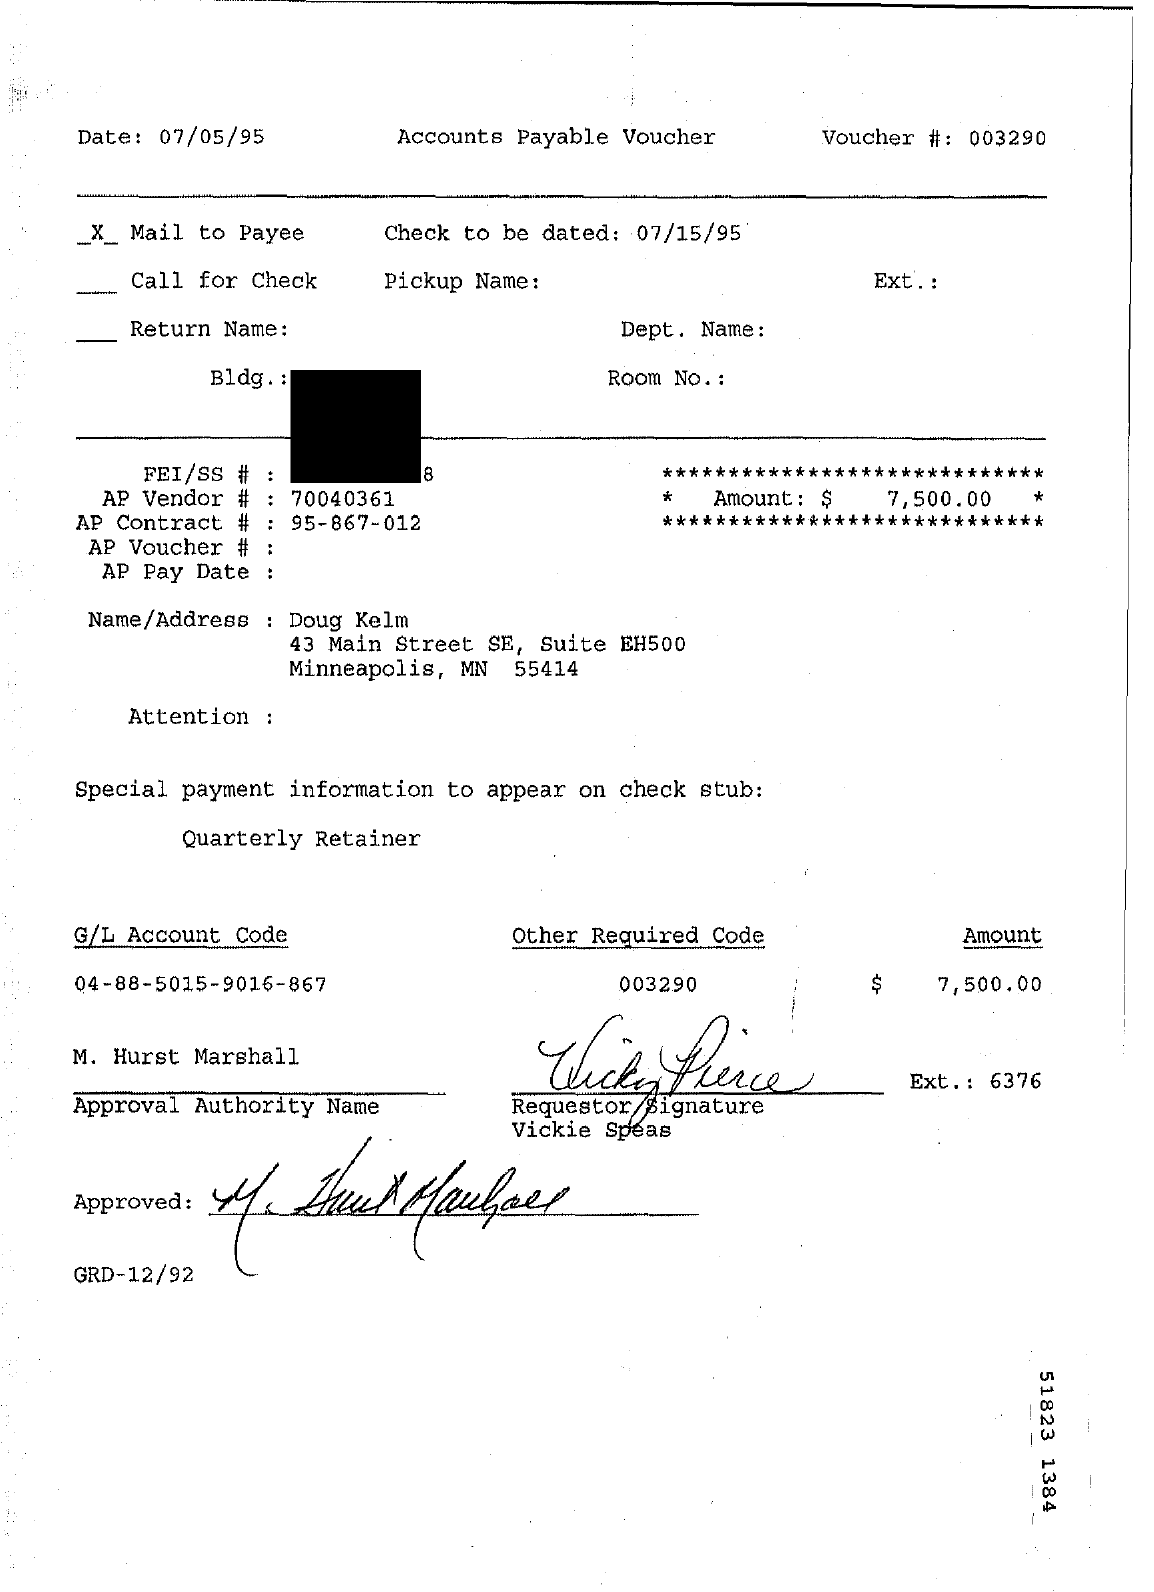Specify some key components in this picture. The AP Contract number is 95-867-012. The AP vendor number is 70040361. The check is to be dated on July 15, 1995. The document bears the date "07/05/95. The voucher number is 003290... 